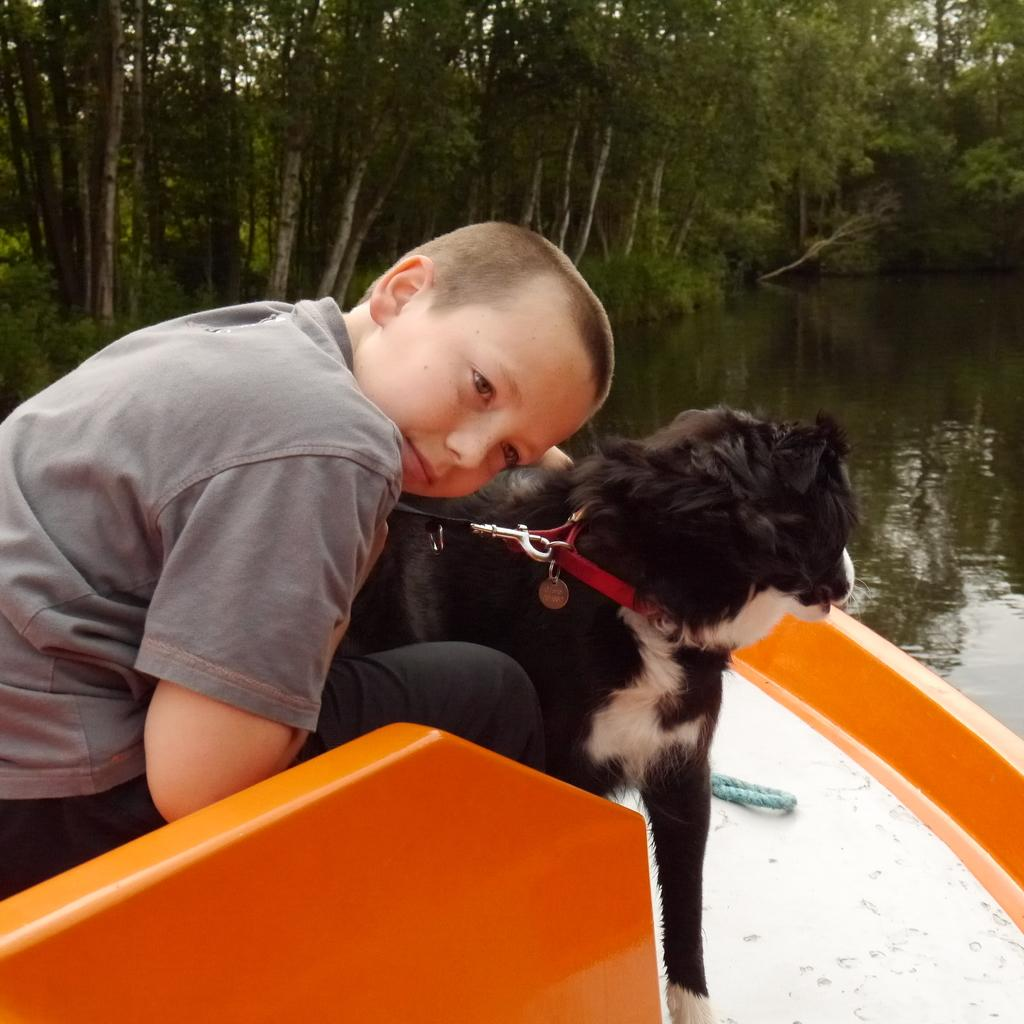What is the person in the image doing? There is a person sitting in a boat in the image. What color is the boat? The boat is black. What can be seen behind the boat? There is water visible at the back of the boat. What type of vegetation is near the water? There are trees near the water. What type of marble is used to build the boat in the image? There is no marble used to build the boat in the image; it is a black boat made of other materials. 